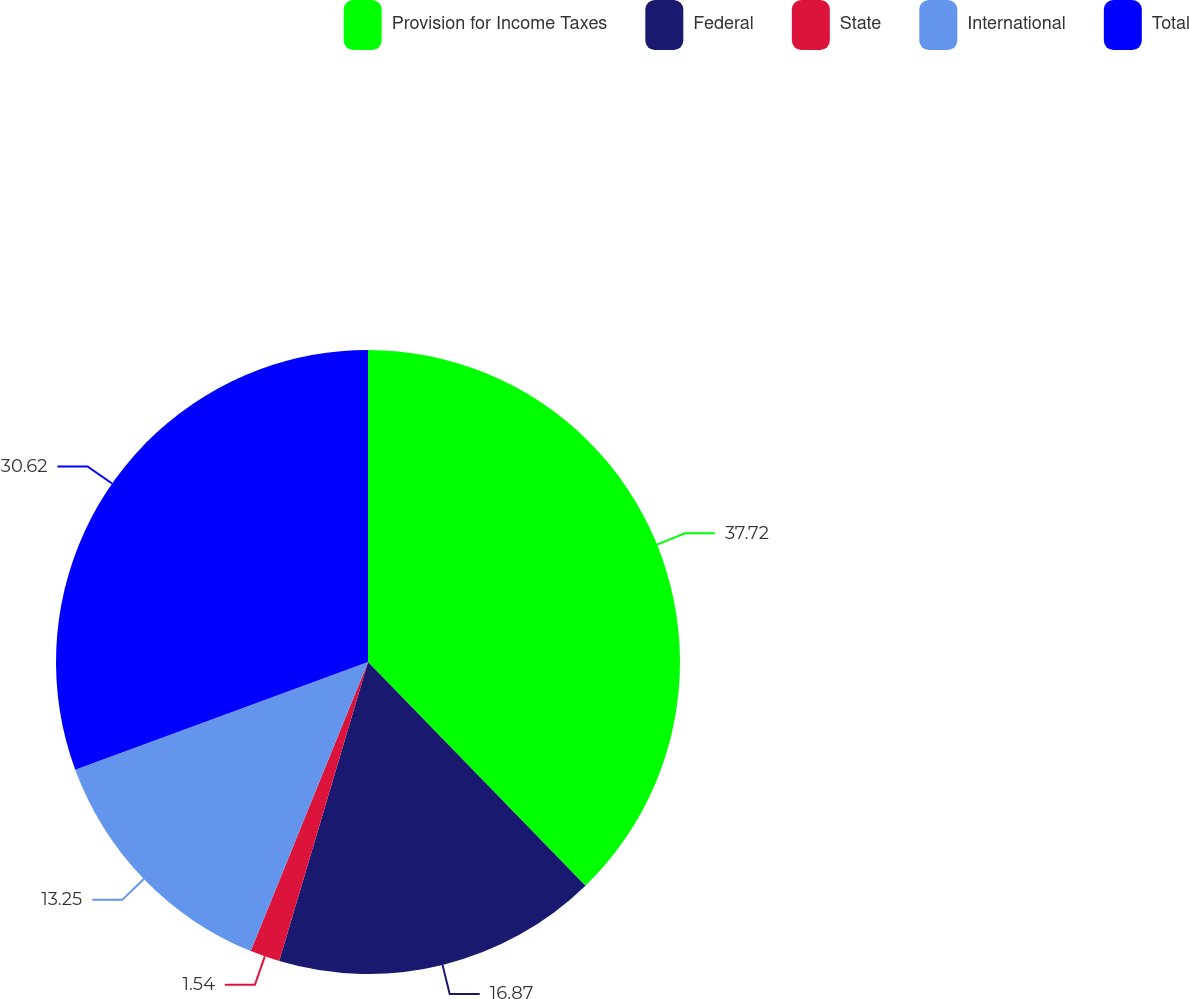Convert chart to OTSL. <chart><loc_0><loc_0><loc_500><loc_500><pie_chart><fcel>Provision for Income Taxes<fcel>Federal<fcel>State<fcel>International<fcel>Total<nl><fcel>37.73%<fcel>16.87%<fcel>1.54%<fcel>13.25%<fcel>30.62%<nl></chart> 